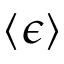Convert formula to latex. <formula><loc_0><loc_0><loc_500><loc_500>\langle \epsilon \rangle</formula> 